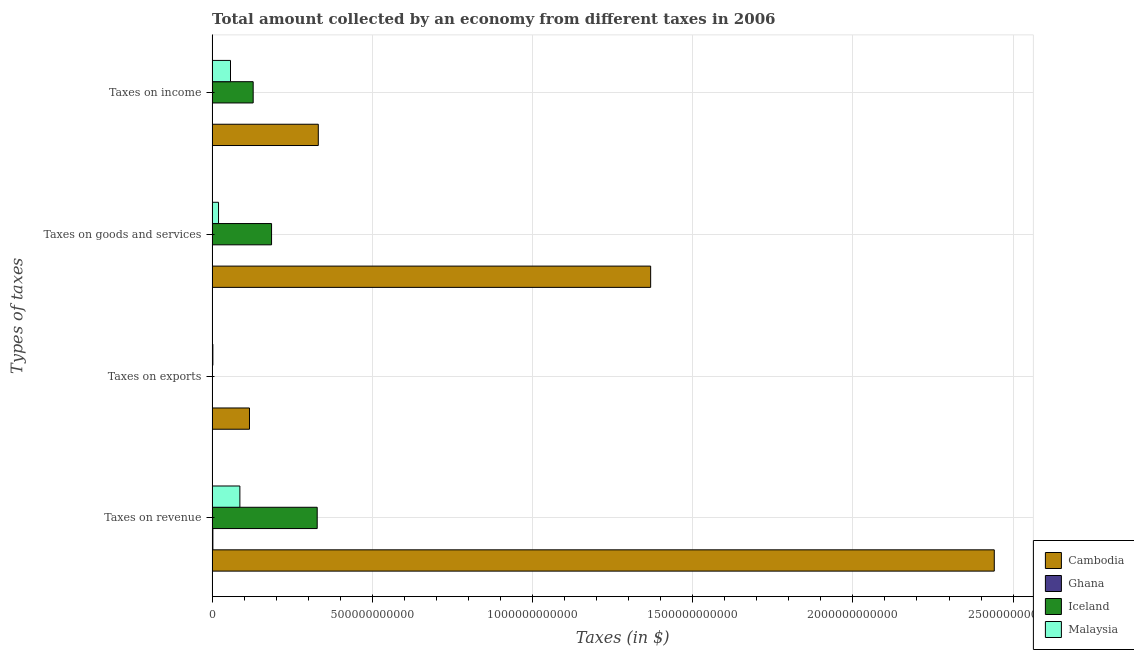How many different coloured bars are there?
Give a very brief answer. 4. How many groups of bars are there?
Give a very brief answer. 4. Are the number of bars per tick equal to the number of legend labels?
Keep it short and to the point. Yes. Are the number of bars on each tick of the Y-axis equal?
Provide a succinct answer. Yes. What is the label of the 4th group of bars from the top?
Your response must be concise. Taxes on revenue. What is the amount collected as tax on goods in Cambodia?
Offer a very short reply. 1.37e+12. Across all countries, what is the maximum amount collected as tax on revenue?
Provide a short and direct response. 2.44e+12. Across all countries, what is the minimum amount collected as tax on exports?
Your response must be concise. 3.10e+06. In which country was the amount collected as tax on exports maximum?
Provide a succinct answer. Cambodia. In which country was the amount collected as tax on revenue minimum?
Offer a very short reply. Ghana. What is the total amount collected as tax on exports in the graph?
Give a very brief answer. 1.19e+11. What is the difference between the amount collected as tax on income in Cambodia and that in Iceland?
Ensure brevity in your answer.  2.03e+11. What is the difference between the amount collected as tax on goods in Ghana and the amount collected as tax on exports in Iceland?
Your answer should be very brief. 1.19e+09. What is the average amount collected as tax on exports per country?
Provide a succinct answer. 2.98e+1. What is the difference between the amount collected as tax on exports and amount collected as tax on revenue in Ghana?
Provide a succinct answer. -2.27e+09. What is the ratio of the amount collected as tax on revenue in Iceland to that in Ghana?
Your answer should be compact. 136.91. Is the amount collected as tax on income in Ghana less than that in Iceland?
Give a very brief answer. Yes. Is the difference between the amount collected as tax on income in Iceland and Malaysia greater than the difference between the amount collected as tax on exports in Iceland and Malaysia?
Your response must be concise. Yes. What is the difference between the highest and the second highest amount collected as tax on exports?
Offer a very short reply. 1.14e+11. What is the difference between the highest and the lowest amount collected as tax on income?
Ensure brevity in your answer.  3.31e+11. In how many countries, is the amount collected as tax on goods greater than the average amount collected as tax on goods taken over all countries?
Keep it short and to the point. 1. Is it the case that in every country, the sum of the amount collected as tax on income and amount collected as tax on goods is greater than the sum of amount collected as tax on exports and amount collected as tax on revenue?
Offer a very short reply. No. What does the 3rd bar from the top in Taxes on income represents?
Your answer should be compact. Ghana. What does the 4th bar from the bottom in Taxes on exports represents?
Give a very brief answer. Malaysia. Is it the case that in every country, the sum of the amount collected as tax on revenue and amount collected as tax on exports is greater than the amount collected as tax on goods?
Make the answer very short. Yes. How many bars are there?
Ensure brevity in your answer.  16. Are all the bars in the graph horizontal?
Offer a very short reply. Yes. How many countries are there in the graph?
Make the answer very short. 4. What is the difference between two consecutive major ticks on the X-axis?
Your answer should be compact. 5.00e+11. Does the graph contain any zero values?
Your answer should be very brief. No. Where does the legend appear in the graph?
Provide a short and direct response. Bottom right. What is the title of the graph?
Keep it short and to the point. Total amount collected by an economy from different taxes in 2006. What is the label or title of the X-axis?
Provide a succinct answer. Taxes (in $). What is the label or title of the Y-axis?
Keep it short and to the point. Types of taxes. What is the Taxes (in $) of Cambodia in Taxes on revenue?
Provide a short and direct response. 2.44e+12. What is the Taxes (in $) of Ghana in Taxes on revenue?
Keep it short and to the point. 2.40e+09. What is the Taxes (in $) in Iceland in Taxes on revenue?
Provide a short and direct response. 3.28e+11. What is the Taxes (in $) of Malaysia in Taxes on revenue?
Provide a short and direct response. 8.66e+1. What is the Taxes (in $) in Cambodia in Taxes on exports?
Offer a very short reply. 1.17e+11. What is the Taxes (in $) of Ghana in Taxes on exports?
Make the answer very short. 1.25e+08. What is the Taxes (in $) in Iceland in Taxes on exports?
Keep it short and to the point. 3.10e+06. What is the Taxes (in $) of Malaysia in Taxes on exports?
Keep it short and to the point. 2.36e+09. What is the Taxes (in $) in Cambodia in Taxes on goods and services?
Your answer should be compact. 1.37e+12. What is the Taxes (in $) of Ghana in Taxes on goods and services?
Your answer should be very brief. 1.20e+09. What is the Taxes (in $) of Iceland in Taxes on goods and services?
Your response must be concise. 1.86e+11. What is the Taxes (in $) in Malaysia in Taxes on goods and services?
Make the answer very short. 2.00e+1. What is the Taxes (in $) in Cambodia in Taxes on income?
Offer a terse response. 3.31e+11. What is the Taxes (in $) in Ghana in Taxes on income?
Offer a very short reply. 6.58e+08. What is the Taxes (in $) in Iceland in Taxes on income?
Offer a very short reply. 1.28e+11. What is the Taxes (in $) of Malaysia in Taxes on income?
Provide a short and direct response. 5.73e+1. Across all Types of taxes, what is the maximum Taxes (in $) of Cambodia?
Your answer should be compact. 2.44e+12. Across all Types of taxes, what is the maximum Taxes (in $) of Ghana?
Your answer should be very brief. 2.40e+09. Across all Types of taxes, what is the maximum Taxes (in $) of Iceland?
Provide a succinct answer. 3.28e+11. Across all Types of taxes, what is the maximum Taxes (in $) of Malaysia?
Ensure brevity in your answer.  8.66e+1. Across all Types of taxes, what is the minimum Taxes (in $) in Cambodia?
Make the answer very short. 1.17e+11. Across all Types of taxes, what is the minimum Taxes (in $) in Ghana?
Offer a terse response. 1.25e+08. Across all Types of taxes, what is the minimum Taxes (in $) of Iceland?
Offer a very short reply. 3.10e+06. Across all Types of taxes, what is the minimum Taxes (in $) of Malaysia?
Offer a very short reply. 2.36e+09. What is the total Taxes (in $) of Cambodia in the graph?
Offer a very short reply. 4.26e+12. What is the total Taxes (in $) in Ghana in the graph?
Ensure brevity in your answer.  4.37e+09. What is the total Taxes (in $) in Iceland in the graph?
Provide a succinct answer. 6.42e+11. What is the total Taxes (in $) in Malaysia in the graph?
Your answer should be compact. 1.66e+11. What is the difference between the Taxes (in $) of Cambodia in Taxes on revenue and that in Taxes on exports?
Keep it short and to the point. 2.32e+12. What is the difference between the Taxes (in $) of Ghana in Taxes on revenue and that in Taxes on exports?
Offer a terse response. 2.27e+09. What is the difference between the Taxes (in $) of Iceland in Taxes on revenue and that in Taxes on exports?
Keep it short and to the point. 3.28e+11. What is the difference between the Taxes (in $) of Malaysia in Taxes on revenue and that in Taxes on exports?
Provide a succinct answer. 8.43e+1. What is the difference between the Taxes (in $) in Cambodia in Taxes on revenue and that in Taxes on goods and services?
Offer a terse response. 1.07e+12. What is the difference between the Taxes (in $) of Ghana in Taxes on revenue and that in Taxes on goods and services?
Offer a very short reply. 1.20e+09. What is the difference between the Taxes (in $) of Iceland in Taxes on revenue and that in Taxes on goods and services?
Your answer should be very brief. 1.42e+11. What is the difference between the Taxes (in $) in Malaysia in Taxes on revenue and that in Taxes on goods and services?
Provide a succinct answer. 6.66e+1. What is the difference between the Taxes (in $) of Cambodia in Taxes on revenue and that in Taxes on income?
Keep it short and to the point. 2.11e+12. What is the difference between the Taxes (in $) of Ghana in Taxes on revenue and that in Taxes on income?
Offer a terse response. 1.74e+09. What is the difference between the Taxes (in $) in Iceland in Taxes on revenue and that in Taxes on income?
Ensure brevity in your answer.  2.00e+11. What is the difference between the Taxes (in $) of Malaysia in Taxes on revenue and that in Taxes on income?
Your answer should be very brief. 2.93e+1. What is the difference between the Taxes (in $) of Cambodia in Taxes on exports and that in Taxes on goods and services?
Keep it short and to the point. -1.25e+12. What is the difference between the Taxes (in $) in Ghana in Taxes on exports and that in Taxes on goods and services?
Offer a very short reply. -1.07e+09. What is the difference between the Taxes (in $) in Iceland in Taxes on exports and that in Taxes on goods and services?
Provide a short and direct response. -1.86e+11. What is the difference between the Taxes (in $) in Malaysia in Taxes on exports and that in Taxes on goods and services?
Offer a terse response. -1.77e+1. What is the difference between the Taxes (in $) in Cambodia in Taxes on exports and that in Taxes on income?
Keep it short and to the point. -2.15e+11. What is the difference between the Taxes (in $) in Ghana in Taxes on exports and that in Taxes on income?
Provide a short and direct response. -5.33e+08. What is the difference between the Taxes (in $) in Iceland in Taxes on exports and that in Taxes on income?
Your answer should be compact. -1.28e+11. What is the difference between the Taxes (in $) in Malaysia in Taxes on exports and that in Taxes on income?
Give a very brief answer. -5.50e+1. What is the difference between the Taxes (in $) in Cambodia in Taxes on goods and services and that in Taxes on income?
Offer a very short reply. 1.04e+12. What is the difference between the Taxes (in $) in Ghana in Taxes on goods and services and that in Taxes on income?
Make the answer very short. 5.37e+08. What is the difference between the Taxes (in $) of Iceland in Taxes on goods and services and that in Taxes on income?
Your answer should be very brief. 5.74e+1. What is the difference between the Taxes (in $) of Malaysia in Taxes on goods and services and that in Taxes on income?
Your answer should be very brief. -3.73e+1. What is the difference between the Taxes (in $) in Cambodia in Taxes on revenue and the Taxes (in $) in Ghana in Taxes on exports?
Your answer should be compact. 2.44e+12. What is the difference between the Taxes (in $) in Cambodia in Taxes on revenue and the Taxes (in $) in Iceland in Taxes on exports?
Keep it short and to the point. 2.44e+12. What is the difference between the Taxes (in $) in Cambodia in Taxes on revenue and the Taxes (in $) in Malaysia in Taxes on exports?
Your answer should be very brief. 2.44e+12. What is the difference between the Taxes (in $) of Ghana in Taxes on revenue and the Taxes (in $) of Iceland in Taxes on exports?
Your answer should be compact. 2.39e+09. What is the difference between the Taxes (in $) of Ghana in Taxes on revenue and the Taxes (in $) of Malaysia in Taxes on exports?
Offer a very short reply. 3.41e+07. What is the difference between the Taxes (in $) in Iceland in Taxes on revenue and the Taxes (in $) in Malaysia in Taxes on exports?
Make the answer very short. 3.26e+11. What is the difference between the Taxes (in $) in Cambodia in Taxes on revenue and the Taxes (in $) in Ghana in Taxes on goods and services?
Provide a short and direct response. 2.44e+12. What is the difference between the Taxes (in $) in Cambodia in Taxes on revenue and the Taxes (in $) in Iceland in Taxes on goods and services?
Your answer should be compact. 2.26e+12. What is the difference between the Taxes (in $) of Cambodia in Taxes on revenue and the Taxes (in $) of Malaysia in Taxes on goods and services?
Give a very brief answer. 2.42e+12. What is the difference between the Taxes (in $) in Ghana in Taxes on revenue and the Taxes (in $) in Iceland in Taxes on goods and services?
Provide a succinct answer. -1.83e+11. What is the difference between the Taxes (in $) in Ghana in Taxes on revenue and the Taxes (in $) in Malaysia in Taxes on goods and services?
Make the answer very short. -1.76e+1. What is the difference between the Taxes (in $) in Iceland in Taxes on revenue and the Taxes (in $) in Malaysia in Taxes on goods and services?
Provide a short and direct response. 3.08e+11. What is the difference between the Taxes (in $) in Cambodia in Taxes on revenue and the Taxes (in $) in Ghana in Taxes on income?
Your answer should be very brief. 2.44e+12. What is the difference between the Taxes (in $) of Cambodia in Taxes on revenue and the Taxes (in $) of Iceland in Taxes on income?
Keep it short and to the point. 2.31e+12. What is the difference between the Taxes (in $) of Cambodia in Taxes on revenue and the Taxes (in $) of Malaysia in Taxes on income?
Provide a succinct answer. 2.38e+12. What is the difference between the Taxes (in $) in Ghana in Taxes on revenue and the Taxes (in $) in Iceland in Taxes on income?
Offer a very short reply. -1.26e+11. What is the difference between the Taxes (in $) of Ghana in Taxes on revenue and the Taxes (in $) of Malaysia in Taxes on income?
Keep it short and to the point. -5.50e+1. What is the difference between the Taxes (in $) in Iceland in Taxes on revenue and the Taxes (in $) in Malaysia in Taxes on income?
Provide a succinct answer. 2.71e+11. What is the difference between the Taxes (in $) in Cambodia in Taxes on exports and the Taxes (in $) in Ghana in Taxes on goods and services?
Your response must be concise. 1.15e+11. What is the difference between the Taxes (in $) of Cambodia in Taxes on exports and the Taxes (in $) of Iceland in Taxes on goods and services?
Keep it short and to the point. -6.89e+1. What is the difference between the Taxes (in $) in Cambodia in Taxes on exports and the Taxes (in $) in Malaysia in Taxes on goods and services?
Keep it short and to the point. 9.66e+1. What is the difference between the Taxes (in $) in Ghana in Taxes on exports and the Taxes (in $) in Iceland in Taxes on goods and services?
Provide a succinct answer. -1.85e+11. What is the difference between the Taxes (in $) in Ghana in Taxes on exports and the Taxes (in $) in Malaysia in Taxes on goods and services?
Make the answer very short. -1.99e+1. What is the difference between the Taxes (in $) in Iceland in Taxes on exports and the Taxes (in $) in Malaysia in Taxes on goods and services?
Make the answer very short. -2.00e+1. What is the difference between the Taxes (in $) of Cambodia in Taxes on exports and the Taxes (in $) of Ghana in Taxes on income?
Provide a short and direct response. 1.16e+11. What is the difference between the Taxes (in $) of Cambodia in Taxes on exports and the Taxes (in $) of Iceland in Taxes on income?
Keep it short and to the point. -1.15e+1. What is the difference between the Taxes (in $) in Cambodia in Taxes on exports and the Taxes (in $) in Malaysia in Taxes on income?
Your answer should be very brief. 5.93e+1. What is the difference between the Taxes (in $) of Ghana in Taxes on exports and the Taxes (in $) of Iceland in Taxes on income?
Offer a very short reply. -1.28e+11. What is the difference between the Taxes (in $) in Ghana in Taxes on exports and the Taxes (in $) in Malaysia in Taxes on income?
Provide a succinct answer. -5.72e+1. What is the difference between the Taxes (in $) of Iceland in Taxes on exports and the Taxes (in $) of Malaysia in Taxes on income?
Offer a terse response. -5.73e+1. What is the difference between the Taxes (in $) in Cambodia in Taxes on goods and services and the Taxes (in $) in Ghana in Taxes on income?
Your answer should be very brief. 1.37e+12. What is the difference between the Taxes (in $) in Cambodia in Taxes on goods and services and the Taxes (in $) in Iceland in Taxes on income?
Provide a succinct answer. 1.24e+12. What is the difference between the Taxes (in $) in Cambodia in Taxes on goods and services and the Taxes (in $) in Malaysia in Taxes on income?
Offer a very short reply. 1.31e+12. What is the difference between the Taxes (in $) of Ghana in Taxes on goods and services and the Taxes (in $) of Iceland in Taxes on income?
Make the answer very short. -1.27e+11. What is the difference between the Taxes (in $) in Ghana in Taxes on goods and services and the Taxes (in $) in Malaysia in Taxes on income?
Keep it short and to the point. -5.62e+1. What is the difference between the Taxes (in $) in Iceland in Taxes on goods and services and the Taxes (in $) in Malaysia in Taxes on income?
Your answer should be compact. 1.28e+11. What is the average Taxes (in $) of Cambodia per Types of taxes?
Keep it short and to the point. 1.06e+12. What is the average Taxes (in $) of Ghana per Types of taxes?
Offer a terse response. 1.09e+09. What is the average Taxes (in $) in Iceland per Types of taxes?
Ensure brevity in your answer.  1.60e+11. What is the average Taxes (in $) of Malaysia per Types of taxes?
Ensure brevity in your answer.  4.16e+1. What is the difference between the Taxes (in $) of Cambodia and Taxes (in $) of Ghana in Taxes on revenue?
Your answer should be very brief. 2.44e+12. What is the difference between the Taxes (in $) in Cambodia and Taxes (in $) in Iceland in Taxes on revenue?
Keep it short and to the point. 2.11e+12. What is the difference between the Taxes (in $) of Cambodia and Taxes (in $) of Malaysia in Taxes on revenue?
Your response must be concise. 2.35e+12. What is the difference between the Taxes (in $) of Ghana and Taxes (in $) of Iceland in Taxes on revenue?
Keep it short and to the point. -3.26e+11. What is the difference between the Taxes (in $) of Ghana and Taxes (in $) of Malaysia in Taxes on revenue?
Ensure brevity in your answer.  -8.42e+1. What is the difference between the Taxes (in $) of Iceland and Taxes (in $) of Malaysia in Taxes on revenue?
Your response must be concise. 2.41e+11. What is the difference between the Taxes (in $) in Cambodia and Taxes (in $) in Ghana in Taxes on exports?
Provide a short and direct response. 1.17e+11. What is the difference between the Taxes (in $) in Cambodia and Taxes (in $) in Iceland in Taxes on exports?
Keep it short and to the point. 1.17e+11. What is the difference between the Taxes (in $) of Cambodia and Taxes (in $) of Malaysia in Taxes on exports?
Offer a terse response. 1.14e+11. What is the difference between the Taxes (in $) of Ghana and Taxes (in $) of Iceland in Taxes on exports?
Your response must be concise. 1.22e+08. What is the difference between the Taxes (in $) of Ghana and Taxes (in $) of Malaysia in Taxes on exports?
Your answer should be compact. -2.24e+09. What is the difference between the Taxes (in $) of Iceland and Taxes (in $) of Malaysia in Taxes on exports?
Provide a succinct answer. -2.36e+09. What is the difference between the Taxes (in $) in Cambodia and Taxes (in $) in Ghana in Taxes on goods and services?
Provide a succinct answer. 1.37e+12. What is the difference between the Taxes (in $) in Cambodia and Taxes (in $) in Iceland in Taxes on goods and services?
Offer a very short reply. 1.18e+12. What is the difference between the Taxes (in $) of Cambodia and Taxes (in $) of Malaysia in Taxes on goods and services?
Your answer should be compact. 1.35e+12. What is the difference between the Taxes (in $) of Ghana and Taxes (in $) of Iceland in Taxes on goods and services?
Ensure brevity in your answer.  -1.84e+11. What is the difference between the Taxes (in $) in Ghana and Taxes (in $) in Malaysia in Taxes on goods and services?
Offer a very short reply. -1.88e+1. What is the difference between the Taxes (in $) of Iceland and Taxes (in $) of Malaysia in Taxes on goods and services?
Offer a terse response. 1.66e+11. What is the difference between the Taxes (in $) in Cambodia and Taxes (in $) in Ghana in Taxes on income?
Your answer should be compact. 3.31e+11. What is the difference between the Taxes (in $) of Cambodia and Taxes (in $) of Iceland in Taxes on income?
Ensure brevity in your answer.  2.03e+11. What is the difference between the Taxes (in $) in Cambodia and Taxes (in $) in Malaysia in Taxes on income?
Provide a succinct answer. 2.74e+11. What is the difference between the Taxes (in $) of Ghana and Taxes (in $) of Iceland in Taxes on income?
Provide a succinct answer. -1.27e+11. What is the difference between the Taxes (in $) in Ghana and Taxes (in $) in Malaysia in Taxes on income?
Give a very brief answer. -5.67e+1. What is the difference between the Taxes (in $) in Iceland and Taxes (in $) in Malaysia in Taxes on income?
Offer a terse response. 7.08e+1. What is the ratio of the Taxes (in $) of Cambodia in Taxes on revenue to that in Taxes on exports?
Your answer should be compact. 20.93. What is the ratio of the Taxes (in $) in Ghana in Taxes on revenue to that in Taxes on exports?
Provide a succinct answer. 19.19. What is the ratio of the Taxes (in $) in Iceland in Taxes on revenue to that in Taxes on exports?
Make the answer very short. 1.06e+05. What is the ratio of the Taxes (in $) of Malaysia in Taxes on revenue to that in Taxes on exports?
Offer a terse response. 36.68. What is the ratio of the Taxes (in $) in Cambodia in Taxes on revenue to that in Taxes on goods and services?
Give a very brief answer. 1.78. What is the ratio of the Taxes (in $) in Ghana in Taxes on revenue to that in Taxes on goods and services?
Keep it short and to the point. 2. What is the ratio of the Taxes (in $) of Iceland in Taxes on revenue to that in Taxes on goods and services?
Offer a very short reply. 1.77. What is the ratio of the Taxes (in $) of Malaysia in Taxes on revenue to that in Taxes on goods and services?
Make the answer very short. 4.33. What is the ratio of the Taxes (in $) in Cambodia in Taxes on revenue to that in Taxes on income?
Provide a short and direct response. 7.37. What is the ratio of the Taxes (in $) of Ghana in Taxes on revenue to that in Taxes on income?
Make the answer very short. 3.64. What is the ratio of the Taxes (in $) in Iceland in Taxes on revenue to that in Taxes on income?
Give a very brief answer. 2.56. What is the ratio of the Taxes (in $) in Malaysia in Taxes on revenue to that in Taxes on income?
Keep it short and to the point. 1.51. What is the ratio of the Taxes (in $) in Cambodia in Taxes on exports to that in Taxes on goods and services?
Your answer should be compact. 0.09. What is the ratio of the Taxes (in $) of Ghana in Taxes on exports to that in Taxes on goods and services?
Your response must be concise. 0.1. What is the ratio of the Taxes (in $) of Iceland in Taxes on exports to that in Taxes on goods and services?
Make the answer very short. 0. What is the ratio of the Taxes (in $) in Malaysia in Taxes on exports to that in Taxes on goods and services?
Give a very brief answer. 0.12. What is the ratio of the Taxes (in $) of Cambodia in Taxes on exports to that in Taxes on income?
Your response must be concise. 0.35. What is the ratio of the Taxes (in $) of Ghana in Taxes on exports to that in Taxes on income?
Make the answer very short. 0.19. What is the ratio of the Taxes (in $) in Iceland in Taxes on exports to that in Taxes on income?
Keep it short and to the point. 0. What is the ratio of the Taxes (in $) of Malaysia in Taxes on exports to that in Taxes on income?
Provide a succinct answer. 0.04. What is the ratio of the Taxes (in $) of Cambodia in Taxes on goods and services to that in Taxes on income?
Provide a short and direct response. 4.13. What is the ratio of the Taxes (in $) in Ghana in Taxes on goods and services to that in Taxes on income?
Your answer should be very brief. 1.82. What is the ratio of the Taxes (in $) in Iceland in Taxes on goods and services to that in Taxes on income?
Ensure brevity in your answer.  1.45. What is the ratio of the Taxes (in $) in Malaysia in Taxes on goods and services to that in Taxes on income?
Provide a short and direct response. 0.35. What is the difference between the highest and the second highest Taxes (in $) of Cambodia?
Provide a succinct answer. 1.07e+12. What is the difference between the highest and the second highest Taxes (in $) of Ghana?
Your answer should be very brief. 1.20e+09. What is the difference between the highest and the second highest Taxes (in $) in Iceland?
Keep it short and to the point. 1.42e+11. What is the difference between the highest and the second highest Taxes (in $) of Malaysia?
Provide a short and direct response. 2.93e+1. What is the difference between the highest and the lowest Taxes (in $) of Cambodia?
Your response must be concise. 2.32e+12. What is the difference between the highest and the lowest Taxes (in $) of Ghana?
Ensure brevity in your answer.  2.27e+09. What is the difference between the highest and the lowest Taxes (in $) in Iceland?
Your response must be concise. 3.28e+11. What is the difference between the highest and the lowest Taxes (in $) in Malaysia?
Ensure brevity in your answer.  8.43e+1. 